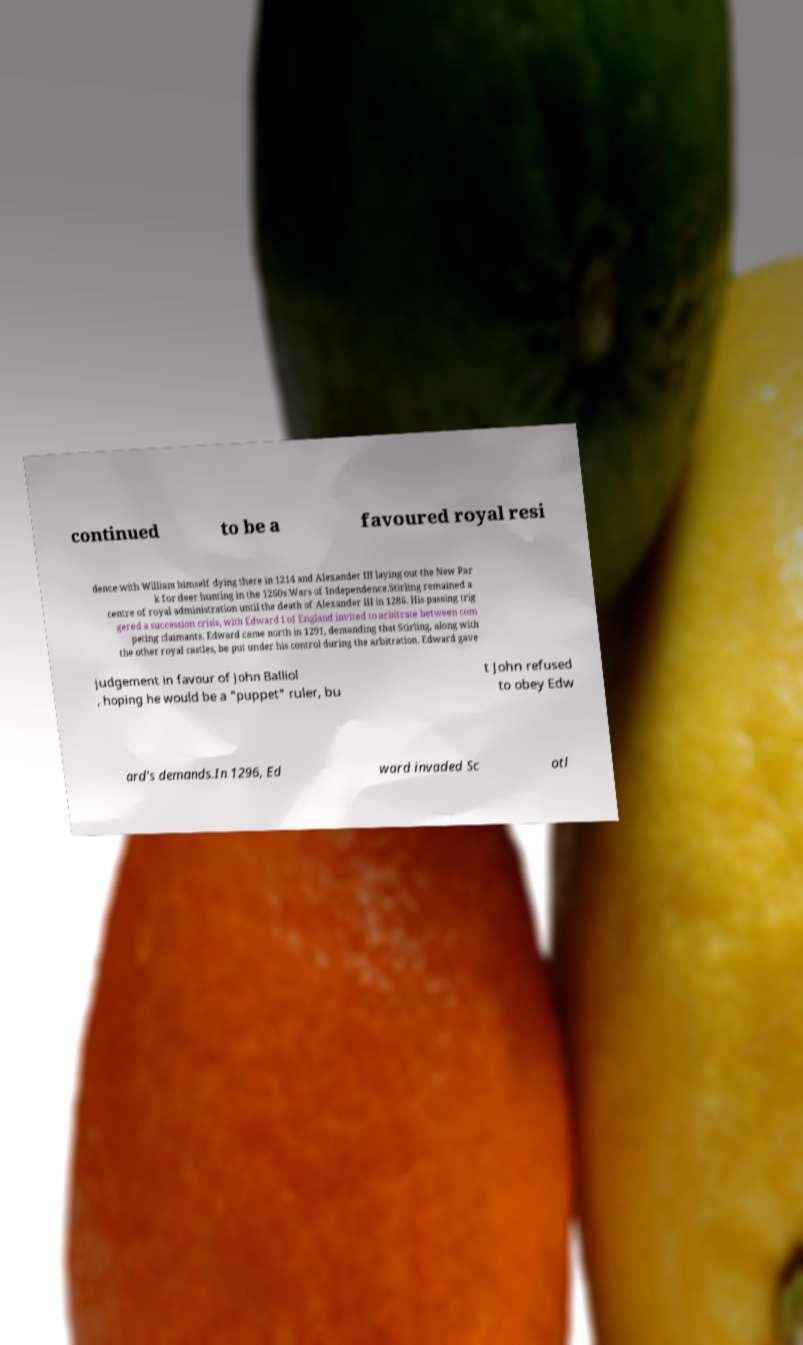Could you assist in decoding the text presented in this image and type it out clearly? continued to be a favoured royal resi dence with William himself dying there in 1214 and Alexander III laying out the New Par k for deer hunting in the 1260s.Wars of Independence.Stirling remained a centre of royal administration until the death of Alexander III in 1286. His passing trig gered a succession crisis, with Edward I of England invited to arbitrate between com peting claimants. Edward came north in 1291, demanding that Stirling, along with the other royal castles, be put under his control during the arbitration. Edward gave judgement in favour of John Balliol , hoping he would be a "puppet" ruler, bu t John refused to obey Edw ard's demands.In 1296, Ed ward invaded Sc otl 